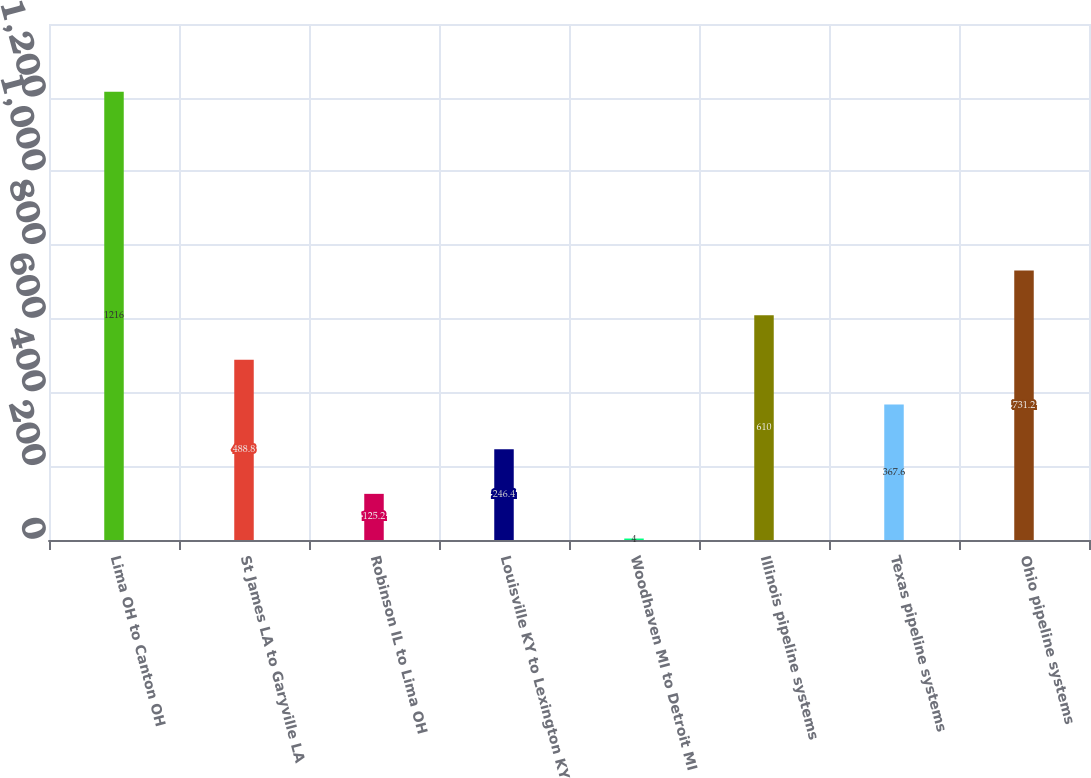Convert chart to OTSL. <chart><loc_0><loc_0><loc_500><loc_500><bar_chart><fcel>Lima OH to Canton OH<fcel>St James LA to Garyville LA<fcel>Robinson IL to Lima OH<fcel>Louisville KY to Lexington KY<fcel>Woodhaven MI to Detroit MI<fcel>Illinois pipeline systems<fcel>Texas pipeline systems<fcel>Ohio pipeline systems<nl><fcel>1216<fcel>488.8<fcel>125.2<fcel>246.4<fcel>4<fcel>610<fcel>367.6<fcel>731.2<nl></chart> 